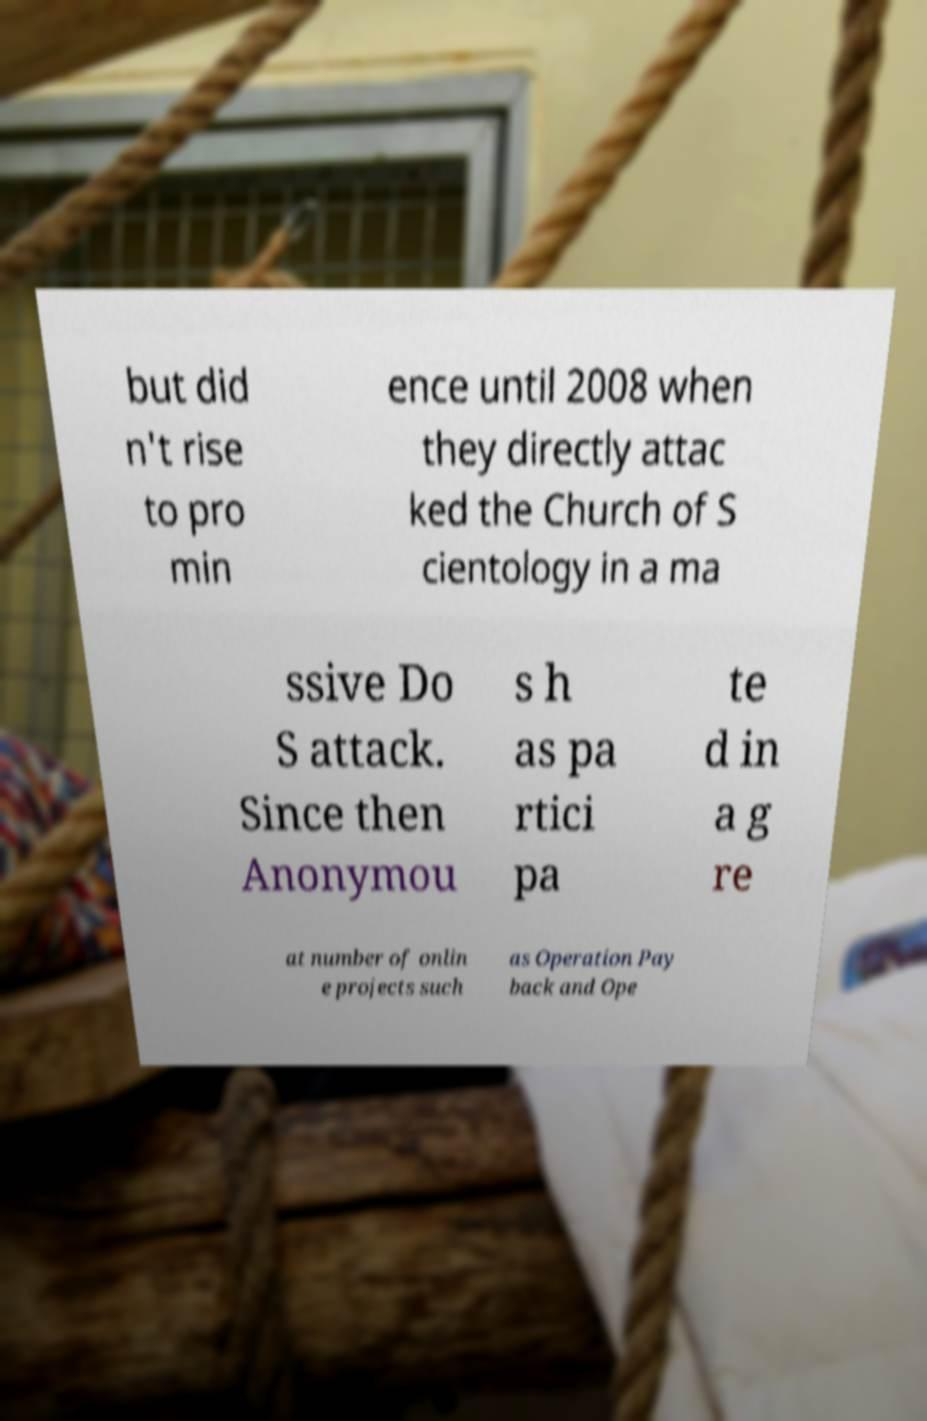Could you extract and type out the text from this image? but did n't rise to pro min ence until 2008 when they directly attac ked the Church of S cientology in a ma ssive Do S attack. Since then Anonymou s h as pa rtici pa te d in a g re at number of onlin e projects such as Operation Pay back and Ope 